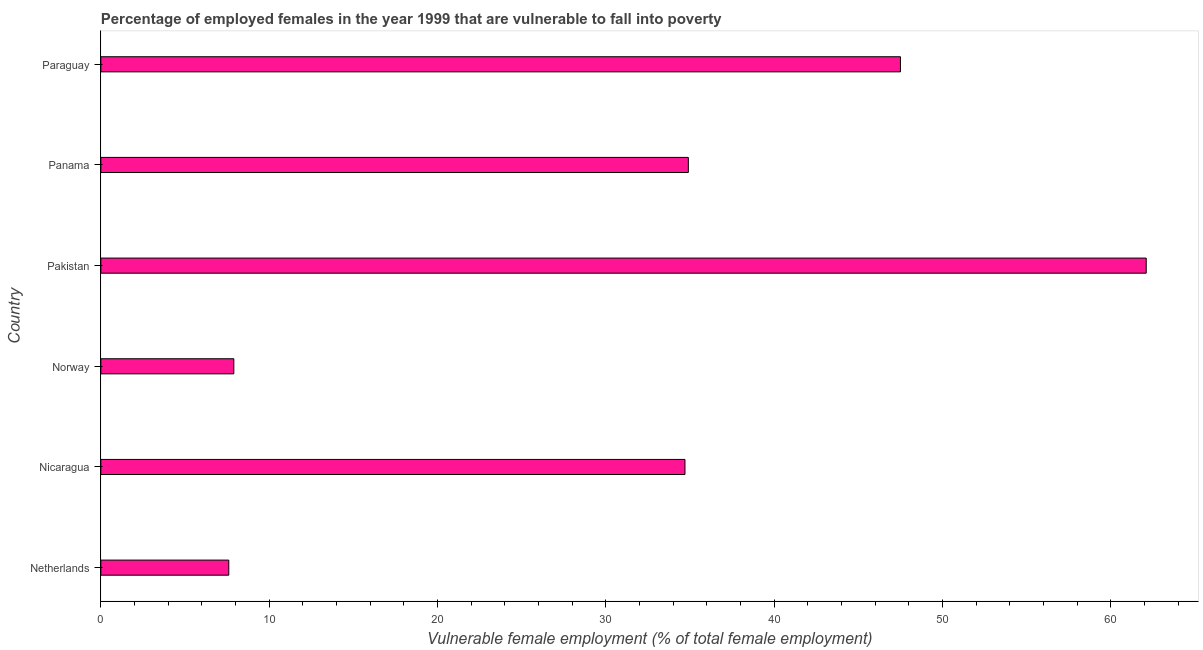What is the title of the graph?
Make the answer very short. Percentage of employed females in the year 1999 that are vulnerable to fall into poverty. What is the label or title of the X-axis?
Keep it short and to the point. Vulnerable female employment (% of total female employment). What is the label or title of the Y-axis?
Ensure brevity in your answer.  Country. What is the percentage of employed females who are vulnerable to fall into poverty in Pakistan?
Your response must be concise. 62.1. Across all countries, what is the maximum percentage of employed females who are vulnerable to fall into poverty?
Make the answer very short. 62.1. Across all countries, what is the minimum percentage of employed females who are vulnerable to fall into poverty?
Make the answer very short. 7.6. In which country was the percentage of employed females who are vulnerable to fall into poverty minimum?
Your answer should be very brief. Netherlands. What is the sum of the percentage of employed females who are vulnerable to fall into poverty?
Offer a terse response. 194.7. What is the average percentage of employed females who are vulnerable to fall into poverty per country?
Give a very brief answer. 32.45. What is the median percentage of employed females who are vulnerable to fall into poverty?
Your answer should be very brief. 34.8. In how many countries, is the percentage of employed females who are vulnerable to fall into poverty greater than 8 %?
Offer a terse response. 4. What is the ratio of the percentage of employed females who are vulnerable to fall into poverty in Pakistan to that in Paraguay?
Offer a very short reply. 1.31. Is the difference between the percentage of employed females who are vulnerable to fall into poverty in Netherlands and Pakistan greater than the difference between any two countries?
Provide a short and direct response. Yes. What is the difference between the highest and the second highest percentage of employed females who are vulnerable to fall into poverty?
Provide a short and direct response. 14.6. Is the sum of the percentage of employed females who are vulnerable to fall into poverty in Norway and Panama greater than the maximum percentage of employed females who are vulnerable to fall into poverty across all countries?
Your answer should be compact. No. What is the difference between the highest and the lowest percentage of employed females who are vulnerable to fall into poverty?
Ensure brevity in your answer.  54.5. How many bars are there?
Make the answer very short. 6. How many countries are there in the graph?
Make the answer very short. 6. Are the values on the major ticks of X-axis written in scientific E-notation?
Offer a terse response. No. What is the Vulnerable female employment (% of total female employment) in Netherlands?
Your response must be concise. 7.6. What is the Vulnerable female employment (% of total female employment) of Nicaragua?
Offer a very short reply. 34.7. What is the Vulnerable female employment (% of total female employment) in Norway?
Offer a terse response. 7.9. What is the Vulnerable female employment (% of total female employment) in Pakistan?
Give a very brief answer. 62.1. What is the Vulnerable female employment (% of total female employment) of Panama?
Keep it short and to the point. 34.9. What is the Vulnerable female employment (% of total female employment) in Paraguay?
Offer a terse response. 47.5. What is the difference between the Vulnerable female employment (% of total female employment) in Netherlands and Nicaragua?
Your answer should be compact. -27.1. What is the difference between the Vulnerable female employment (% of total female employment) in Netherlands and Norway?
Make the answer very short. -0.3. What is the difference between the Vulnerable female employment (% of total female employment) in Netherlands and Pakistan?
Provide a short and direct response. -54.5. What is the difference between the Vulnerable female employment (% of total female employment) in Netherlands and Panama?
Make the answer very short. -27.3. What is the difference between the Vulnerable female employment (% of total female employment) in Netherlands and Paraguay?
Make the answer very short. -39.9. What is the difference between the Vulnerable female employment (% of total female employment) in Nicaragua and Norway?
Your answer should be compact. 26.8. What is the difference between the Vulnerable female employment (% of total female employment) in Nicaragua and Pakistan?
Offer a terse response. -27.4. What is the difference between the Vulnerable female employment (% of total female employment) in Nicaragua and Panama?
Provide a short and direct response. -0.2. What is the difference between the Vulnerable female employment (% of total female employment) in Norway and Pakistan?
Offer a very short reply. -54.2. What is the difference between the Vulnerable female employment (% of total female employment) in Norway and Paraguay?
Your answer should be very brief. -39.6. What is the difference between the Vulnerable female employment (% of total female employment) in Pakistan and Panama?
Offer a very short reply. 27.2. What is the ratio of the Vulnerable female employment (% of total female employment) in Netherlands to that in Nicaragua?
Offer a terse response. 0.22. What is the ratio of the Vulnerable female employment (% of total female employment) in Netherlands to that in Pakistan?
Provide a short and direct response. 0.12. What is the ratio of the Vulnerable female employment (% of total female employment) in Netherlands to that in Panama?
Provide a short and direct response. 0.22. What is the ratio of the Vulnerable female employment (% of total female employment) in Netherlands to that in Paraguay?
Keep it short and to the point. 0.16. What is the ratio of the Vulnerable female employment (% of total female employment) in Nicaragua to that in Norway?
Provide a succinct answer. 4.39. What is the ratio of the Vulnerable female employment (% of total female employment) in Nicaragua to that in Pakistan?
Keep it short and to the point. 0.56. What is the ratio of the Vulnerable female employment (% of total female employment) in Nicaragua to that in Paraguay?
Ensure brevity in your answer.  0.73. What is the ratio of the Vulnerable female employment (% of total female employment) in Norway to that in Pakistan?
Provide a succinct answer. 0.13. What is the ratio of the Vulnerable female employment (% of total female employment) in Norway to that in Panama?
Make the answer very short. 0.23. What is the ratio of the Vulnerable female employment (% of total female employment) in Norway to that in Paraguay?
Your answer should be very brief. 0.17. What is the ratio of the Vulnerable female employment (% of total female employment) in Pakistan to that in Panama?
Provide a succinct answer. 1.78. What is the ratio of the Vulnerable female employment (% of total female employment) in Pakistan to that in Paraguay?
Provide a succinct answer. 1.31. What is the ratio of the Vulnerable female employment (% of total female employment) in Panama to that in Paraguay?
Give a very brief answer. 0.73. 